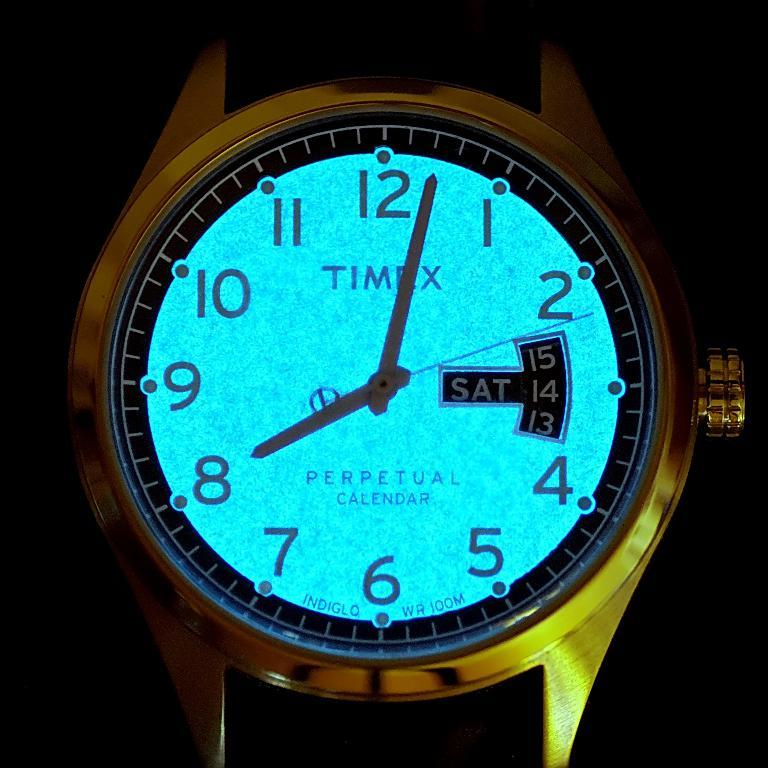<image>
Present a compact description of the photo's key features. Watch that glows and says TIMEX on the screen. 